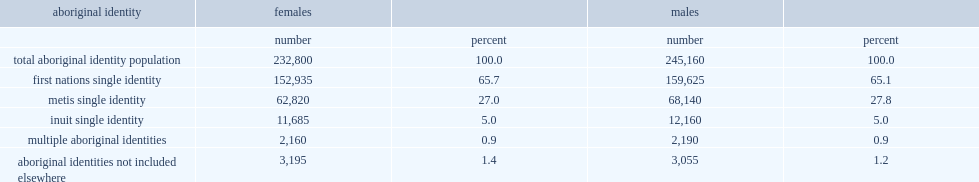What is the percentage of children in canada have aboriginal identity? 0.068098. What is the percentage of girls have first nations single identity? 65.7. What is the percentage of girls have metis single identity? 27.0. What is the percentage of girls have inuit single identity? 5.0. What is the percentage of aboriginal girls had more than one aboriginal identity? 0.9. What is the percentage of aboriginal girls did not identify with a particular aboriginal group? 1.4. 